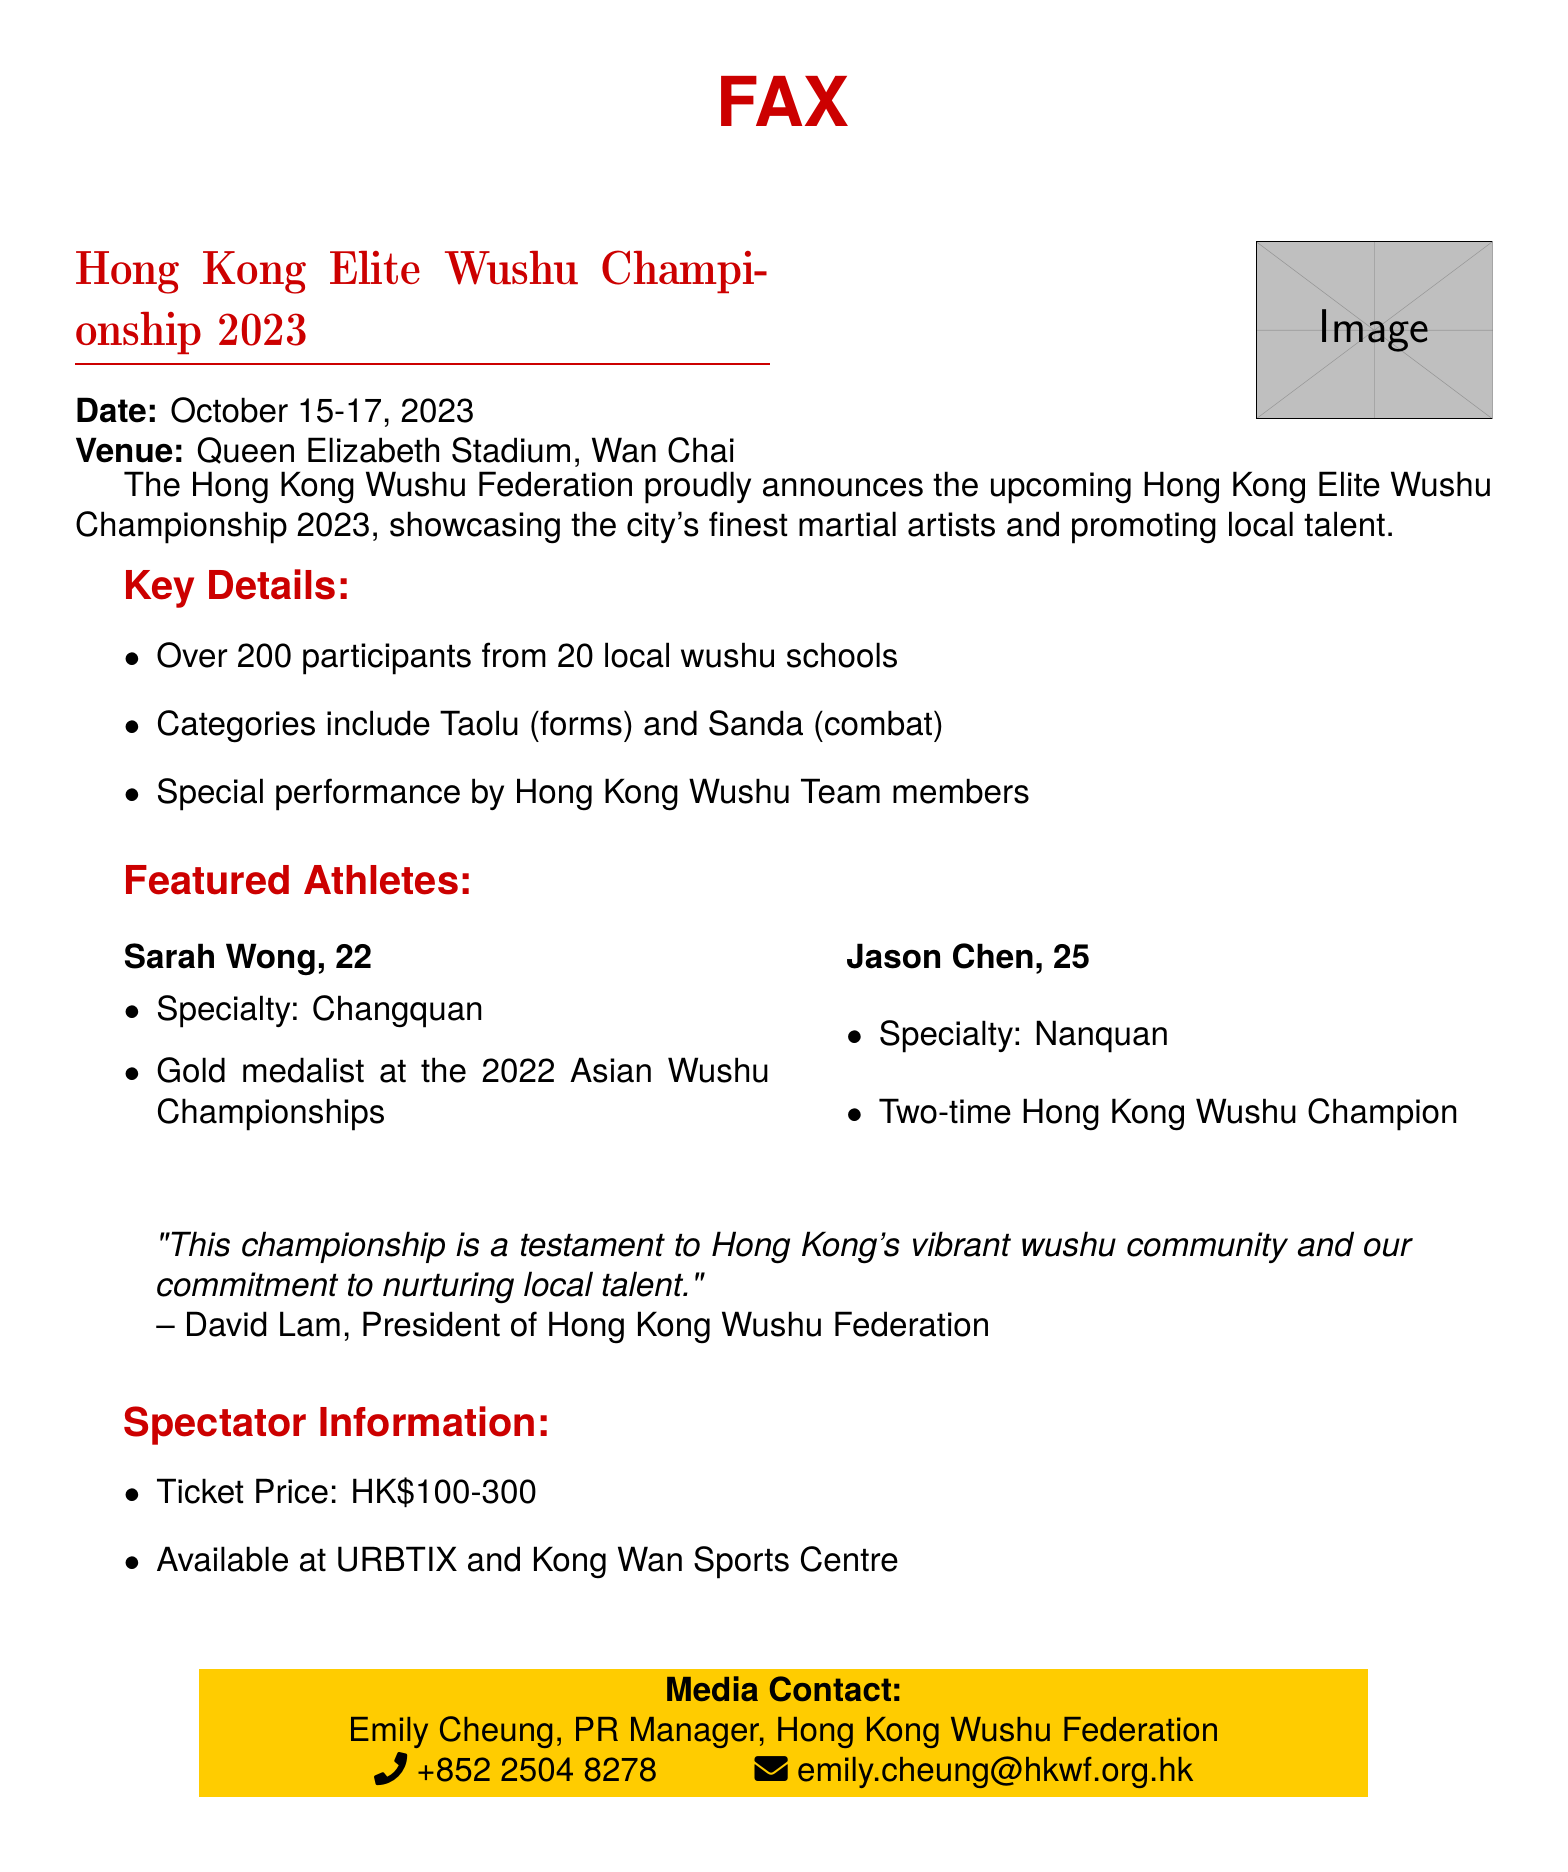What are the dates of the championship? The dates of the championship are provided in the document as October 15-17, 2023.
Answer: October 15-17, 2023 Where is the venue for the event? The document explicitly mentions the venue for the championship as Queen Elizabeth Stadium, Wan Chai.
Answer: Queen Elizabeth Stadium, Wan Chai How many participants will be there? The document states that there will be over 200 participants from 20 local wushu schools, which specifies the number of participants.
Answer: Over 200 participants Who is one of the featured athletes? The document lists Sarah Wong and Jason Chen as featured athletes, providing their names and specialties.
Answer: Sarah Wong What is the ticket price range? The document includes information on ticket prices, stating they range from HK$100-300.
Answer: HK$100-300 What categories are included in the championship? The championship categories are mentioned in the document as Taolu (forms) and Sanda (combat), which provides the categories included.
Answer: Taolu (forms) and Sanda (combat) Who is the President of Hong Kong Wushu Federation? The document quotes David Lam as the President of Hong Kong Wushu Federation.
Answer: David Lam What special performance is mentioned? The document specifies that there will be a special performance by Hong Kong Wushu Team members, indicating a highlight at the championship.
Answer: Special performance by Hong Kong Wushu Team members How can tickets be purchased? The document states that tickets are available at URBTIX and Kong Wan Sports Centre, which explains how to purchase them.
Answer: URBTIX and Kong Wan Sports Centre 